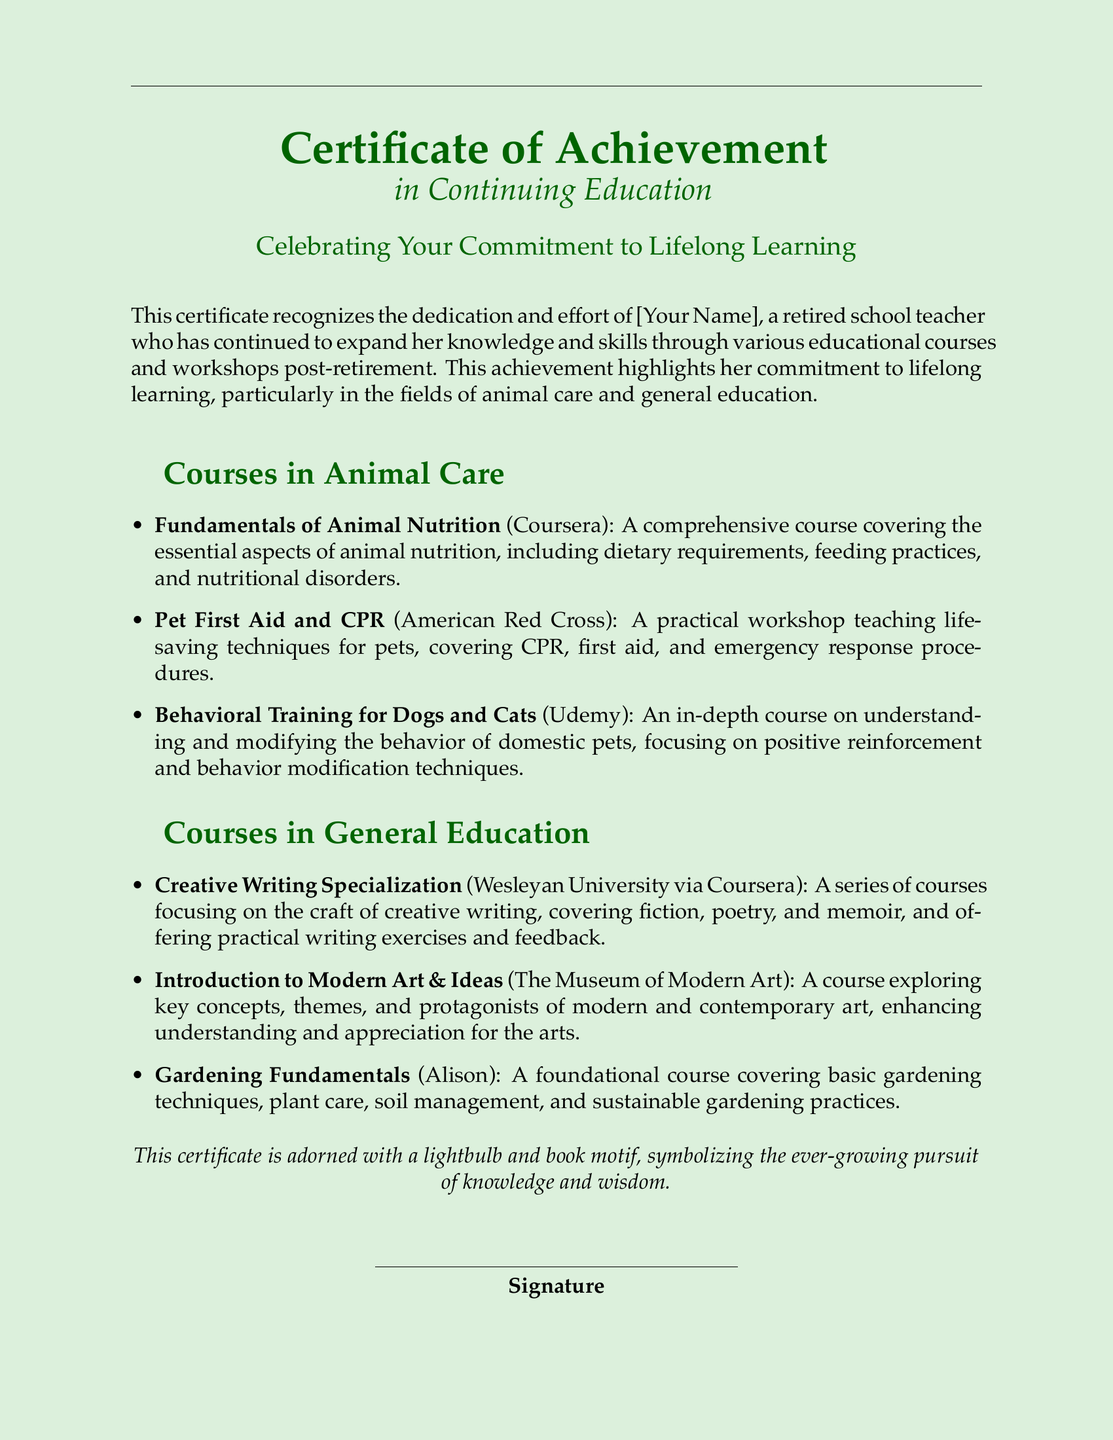What is the title of the certificate? The title of the certificate is clearly stated at the top of the document.
Answer: Certificate of Achievement In what field does the certificate recognize continuing education? The certificate notes the specific focus of the continued education efforts mentioned in the document.
Answer: Continuing Education Who is recognized by this certificate? The name of the individual who achieved this recognition is mentioned directly.
Answer: [Your Name] What are the subjects of the courses listed in Animal Care? The document outlines the specific courses included in the Animal Care section.
Answer: Animal Nutrition, Pet First Aid and CPR, Behavioral Training Which platform offers the course on Behavioral Training for Dogs and Cats? The platforms for the courses are specified in the respective courses listed in the document.
Answer: Udemy What is the motif that decorates the certificate? The document describes a decorative motif present in the certificate.
Answer: Lightbulb and book How many courses are listed under General Education? The document contains a specific list of courses under General Education.
Answer: Three What is the font used in the certificate? The document specifies the font used throughout the certificate as part of the formatting.
Answer: Palatino Which organization offers the Pet First Aid and CPR course? The certificate includes the name of the organization providing the mentioned workshop.
Answer: American Red Cross 